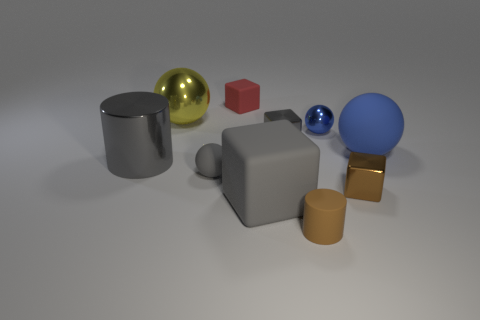Is there anything else that has the same size as the yellow sphere?
Keep it short and to the point. Yes. Are there more tiny gray matte things than large green rubber things?
Your answer should be compact. Yes. How many balls are tiny gray matte things or gray metal things?
Your response must be concise. 1. The small rubber ball has what color?
Ensure brevity in your answer.  Gray. Is the size of the gray shiny object that is on the right side of the large gray cylinder the same as the matte sphere that is in front of the big rubber ball?
Keep it short and to the point. Yes. Are there fewer metal cylinders than big yellow matte cylinders?
Your answer should be compact. No. What number of large metallic things are in front of the tiny blue object?
Your answer should be compact. 1. What is the tiny gray sphere made of?
Offer a very short reply. Rubber. Is the small rubber block the same color as the big rubber ball?
Give a very brief answer. No. Are there fewer big matte blocks that are to the left of the red rubber cube than large blue rubber balls?
Keep it short and to the point. Yes. 